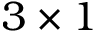Convert formula to latex. <formula><loc_0><loc_0><loc_500><loc_500>3 \times 1</formula> 